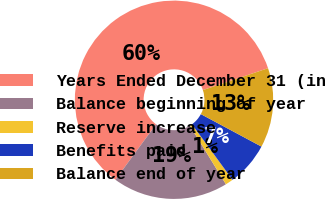<chart> <loc_0><loc_0><loc_500><loc_500><pie_chart><fcel>Years Ended December 31 (in<fcel>Balance beginning of year<fcel>Reserve increase<fcel>Benefits paid<fcel>Balance end of year<nl><fcel>59.78%<fcel>18.83%<fcel>1.28%<fcel>7.13%<fcel>12.98%<nl></chart> 